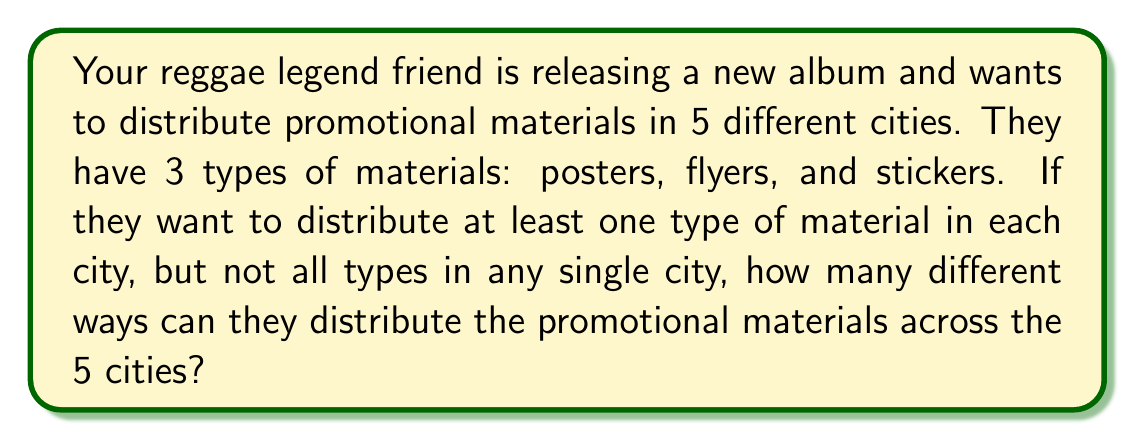Can you answer this question? Let's approach this step-by-step:

1) For each city, we have 3 choices of materials, but we can't use all 3 or none. So, for each city, we have:

   $\binom{3}{1} + \binom{3}{2} = 3 + 3 = 6$ possible combinations

2) We need to make this choice for each of the 5 cities independently. Therefore, we can use the multiplication principle.

3) The total number of ways to distribute the materials is:

   $6^5 = 6 \times 6 \times 6 \times 6 \times 6$

4) Let's calculate this:

   $6^5 = 7,776$

Therefore, there are 7,776 different ways to distribute the promotional materials across the 5 cities.
Answer: 7,776 